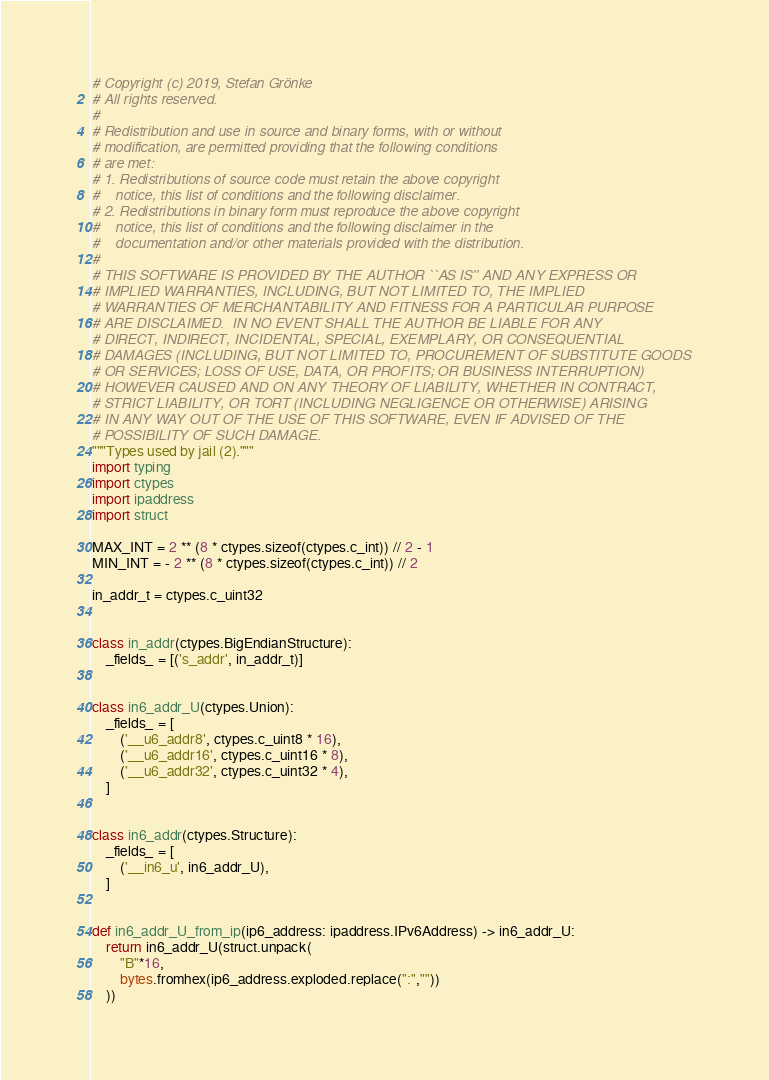<code> <loc_0><loc_0><loc_500><loc_500><_Python_># Copyright (c) 2019, Stefan Grönke
# All rights reserved.
# 
# Redistribution and use in source and binary forms, with or without
# modification, are permitted providing that the following conditions
# are met:
# 1. Redistributions of source code must retain the above copyright
#    notice, this list of conditions and the following disclaimer.
# 2. Redistributions in binary form must reproduce the above copyright
#    notice, this list of conditions and the following disclaimer in the
#    documentation and/or other materials provided with the distribution.
# 
# THIS SOFTWARE IS PROVIDED BY THE AUTHOR ``AS IS'' AND ANY EXPRESS OR
# IMPLIED WARRANTIES, INCLUDING, BUT NOT LIMITED TO, THE IMPLIED
# WARRANTIES OF MERCHANTABILITY AND FITNESS FOR A PARTICULAR PURPOSE
# ARE DISCLAIMED.  IN NO EVENT SHALL THE AUTHOR BE LIABLE FOR ANY
# DIRECT, INDIRECT, INCIDENTAL, SPECIAL, EXEMPLARY, OR CONSEQUENTIAL
# DAMAGES (INCLUDING, BUT NOT LIMITED TO, PROCUREMENT OF SUBSTITUTE GOODS
# OR SERVICES; LOSS OF USE, DATA, OR PROFITS; OR BUSINESS INTERRUPTION)
# HOWEVER CAUSED AND ON ANY THEORY OF LIABILITY, WHETHER IN CONTRACT,
# STRICT LIABILITY, OR TORT (INCLUDING NEGLIGENCE OR OTHERWISE) ARISING
# IN ANY WAY OUT OF THE USE OF THIS SOFTWARE, EVEN IF ADVISED OF THE
# POSSIBILITY OF SUCH DAMAGE.
"""Types used by jail (2)."""
import typing
import ctypes
import ipaddress
import struct

MAX_INT = 2 ** (8 * ctypes.sizeof(ctypes.c_int)) // 2 - 1
MIN_INT = - 2 ** (8 * ctypes.sizeof(ctypes.c_int)) // 2

in_addr_t = ctypes.c_uint32


class in_addr(ctypes.BigEndianStructure):
    _fields_ = [('s_addr', in_addr_t)]


class in6_addr_U(ctypes.Union):
    _fields_ = [
        ('__u6_addr8', ctypes.c_uint8 * 16),
        ('__u6_addr16', ctypes.c_uint16 * 8),
        ('__u6_addr32', ctypes.c_uint32 * 4),
    ]


class in6_addr(ctypes.Structure):
    _fields_ = [
        ('__in6_u', in6_addr_U),
    ]


def in6_addr_U_from_ip(ip6_address: ipaddress.IPv6Address) -> in6_addr_U:
	return in6_addr_U(struct.unpack(
		"B"*16,
		bytes.fromhex(ip6_address.exploded.replace(":",""))
	))
</code> 